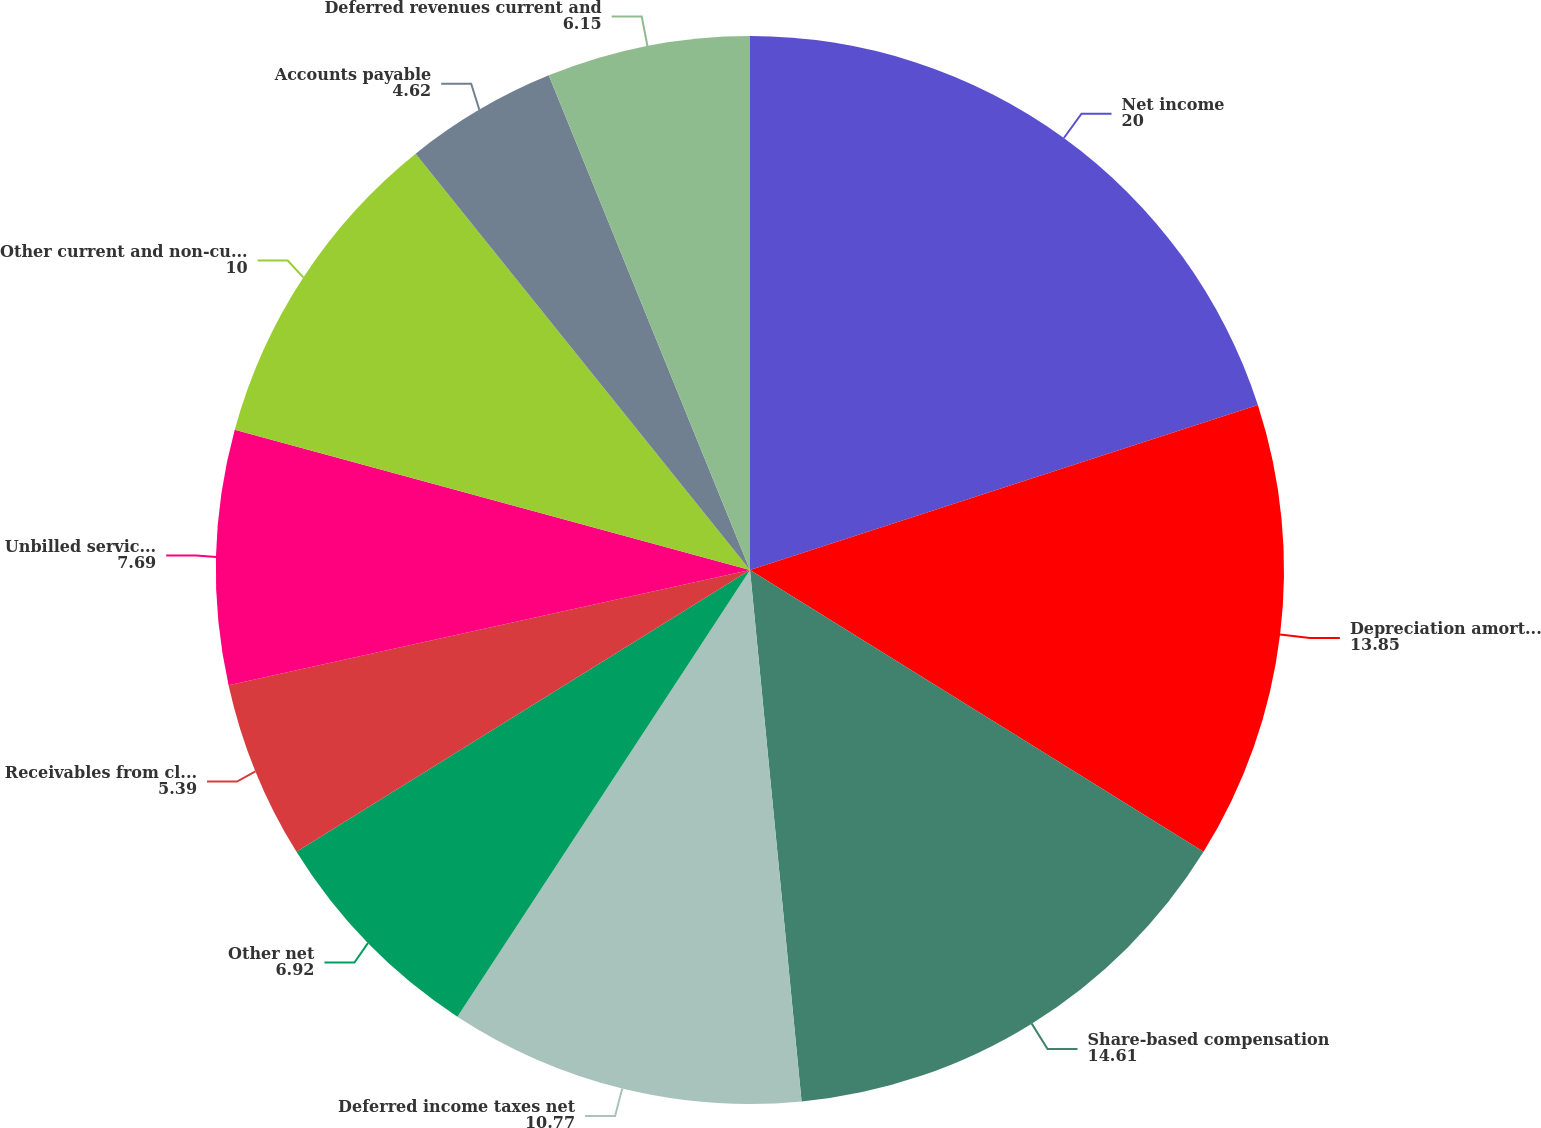Convert chart to OTSL. <chart><loc_0><loc_0><loc_500><loc_500><pie_chart><fcel>Net income<fcel>Depreciation amortization and<fcel>Share-based compensation<fcel>Deferred income taxes net<fcel>Other net<fcel>Receivables from clients net<fcel>Unbilled services current and<fcel>Other current and non-current<fcel>Accounts payable<fcel>Deferred revenues current and<nl><fcel>20.0%<fcel>13.85%<fcel>14.61%<fcel>10.77%<fcel>6.92%<fcel>5.39%<fcel>7.69%<fcel>10.0%<fcel>4.62%<fcel>6.15%<nl></chart> 